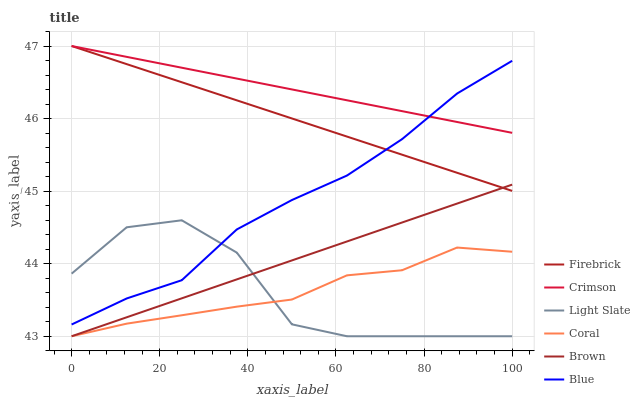Does Light Slate have the minimum area under the curve?
Answer yes or no. Yes. Does Crimson have the maximum area under the curve?
Answer yes or no. Yes. Does Brown have the minimum area under the curve?
Answer yes or no. No. Does Brown have the maximum area under the curve?
Answer yes or no. No. Is Brown the smoothest?
Answer yes or no. Yes. Is Light Slate the roughest?
Answer yes or no. Yes. Is Light Slate the smoothest?
Answer yes or no. No. Is Brown the roughest?
Answer yes or no. No. Does Brown have the lowest value?
Answer yes or no. Yes. Does Firebrick have the lowest value?
Answer yes or no. No. Does Crimson have the highest value?
Answer yes or no. Yes. Does Brown have the highest value?
Answer yes or no. No. Is Coral less than Crimson?
Answer yes or no. Yes. Is Firebrick greater than Light Slate?
Answer yes or no. Yes. Does Coral intersect Brown?
Answer yes or no. Yes. Is Coral less than Brown?
Answer yes or no. No. Is Coral greater than Brown?
Answer yes or no. No. Does Coral intersect Crimson?
Answer yes or no. No. 